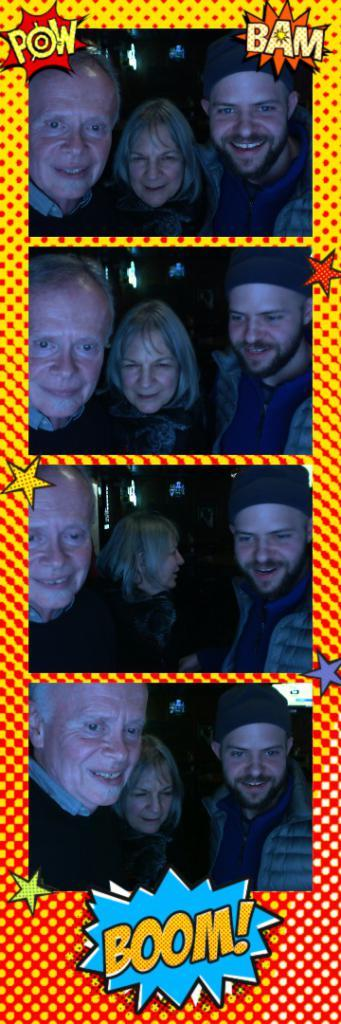How many images are combined to create the collage in the image? The image is a collage of four images. Can you describe the subjects in the images? There are three persons in the images. What is written at the bottom of the collage? There is text at the bottom of the collage. What type of frame is used for the collage? The background appears to be an animated frame. What type of milk is being poured into the glass in the image? There is no glass or milk present in the image; it is a collage of four images with three persons and text at the bottom. What is the angle of the sun in the image? There is no reference to the sun or its angle in the image; it is a collage of four images with three persons and text at the bottom. 